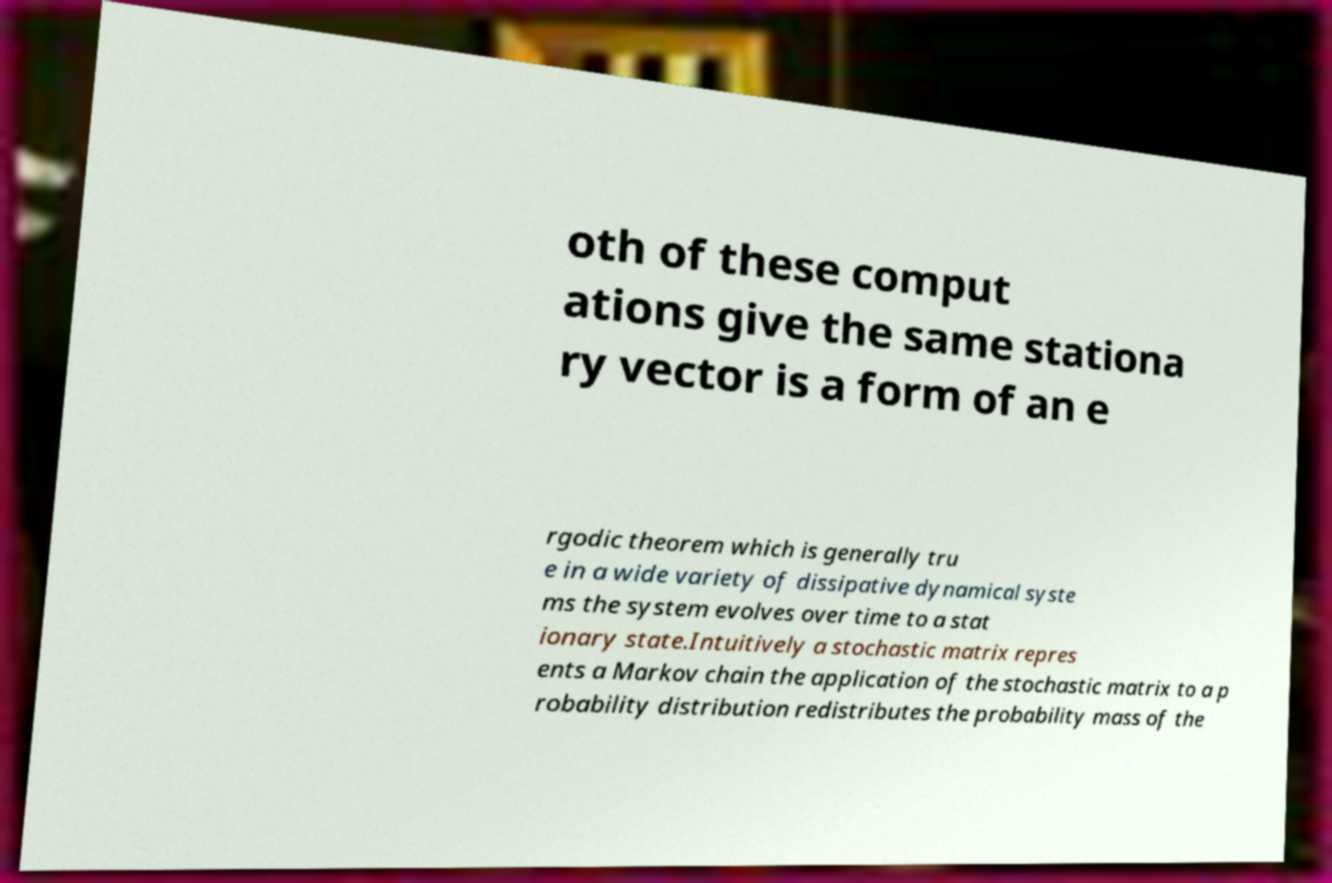Can you read and provide the text displayed in the image?This photo seems to have some interesting text. Can you extract and type it out for me? oth of these comput ations give the same stationa ry vector is a form of an e rgodic theorem which is generally tru e in a wide variety of dissipative dynamical syste ms the system evolves over time to a stat ionary state.Intuitively a stochastic matrix repres ents a Markov chain the application of the stochastic matrix to a p robability distribution redistributes the probability mass of the 